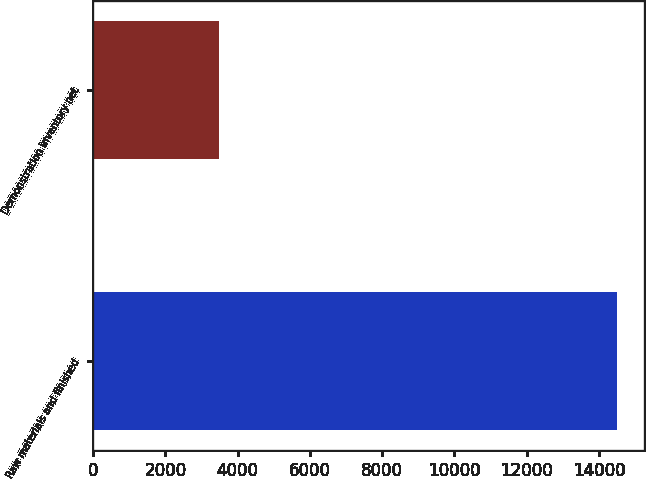Convert chart to OTSL. <chart><loc_0><loc_0><loc_500><loc_500><bar_chart><fcel>Raw materials and finished<fcel>Demonstration inventory net<nl><fcel>14511<fcel>3488<nl></chart> 